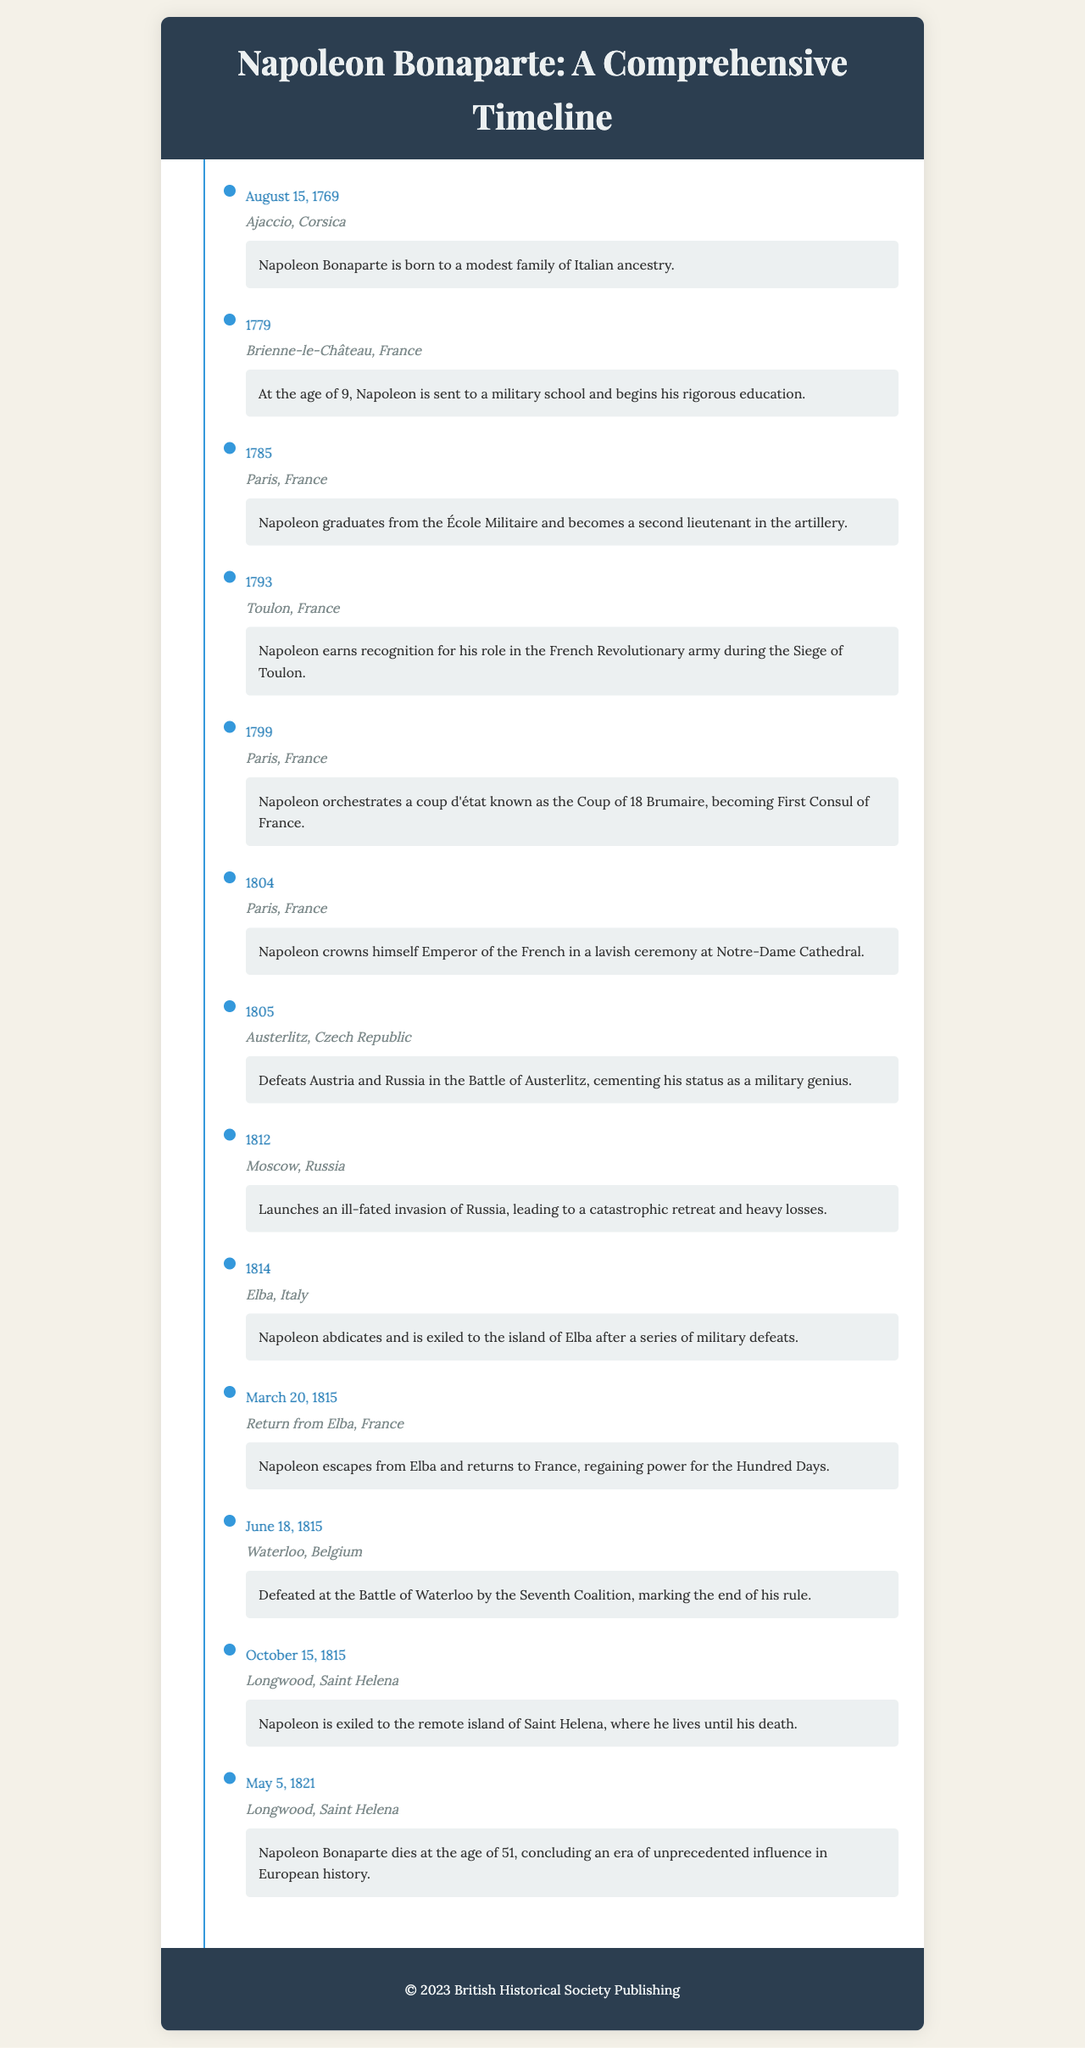What date was Napoleon born? The document states that Napoleon Bonaparte was born on August 15, 1769.
Answer: August 15, 1769 In which location did Napoleon crown himself Emperor? According to the document, Napoleon crowned himself Emperor in Paris, France.
Answer: Paris, France What significant battle did Napoleon win in 1805? The document mentions that he defeated Austria and Russia in the Battle of Austerlitz in 1805.
Answer: Battle of Austerlitz How old was Napoleon when he died? The document indicates that Napoleon died at the age of 51.
Answer: 51 What is the name of the island where Napoleon was exiled? The document specifies that Napoleon was exiled to the island of Elba after military defeats.
Answer: Elba What year did Napoleon escape from Elba? The document states that Napoleon escaped from Elba on March 20, 1815.
Answer: March 20, 1815 Which event marked the end of Napoleon's rule? According to the document, Napoleon was defeated at the Battle of Waterloo, which marked the end of his rule.
Answer: Battle of Waterloo What happened on May 5, 1821? The document notes that Napoleon Bonaparte died on May 5, 1821, concluding his influence.
Answer: Napoleon Bonaparte dies What was Napoleon's role at the age of 16? The document states that Napoleon became a second lieutenant in the artillery in 1785 after graduating from military school.
Answer: Second lieutenant in the artillery 